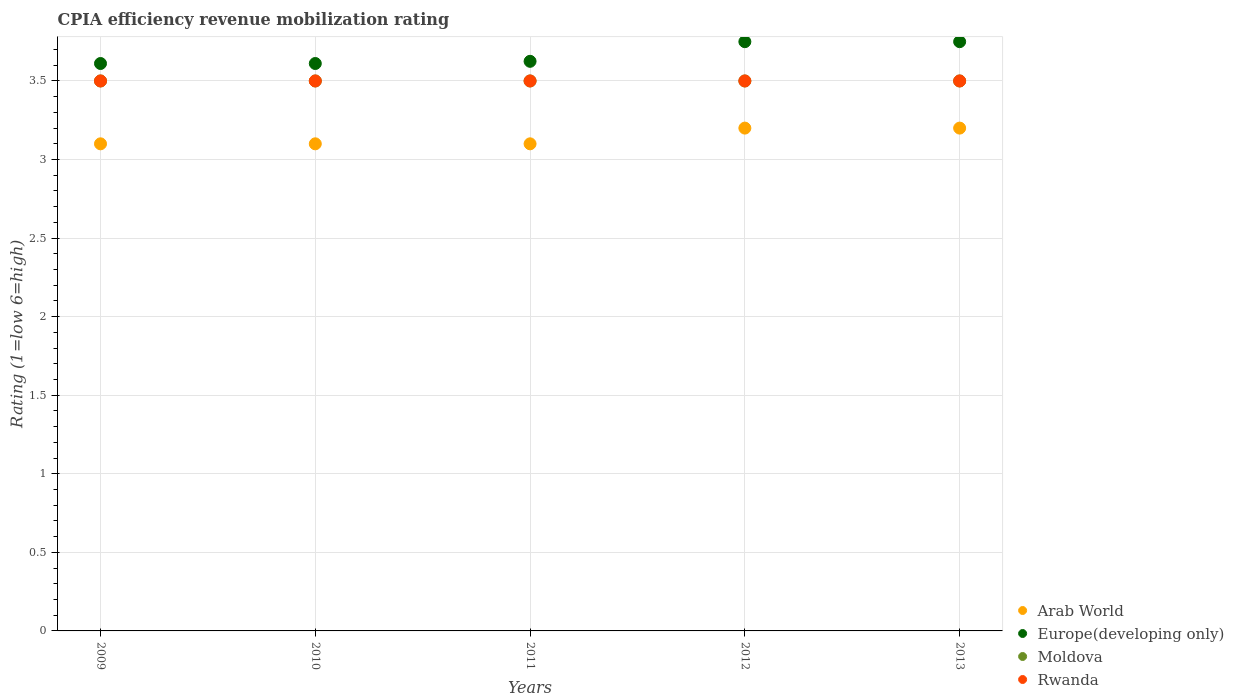Is the number of dotlines equal to the number of legend labels?
Offer a terse response. Yes. What is the CPIA rating in Arab World in 2013?
Your answer should be very brief. 3.2. Across all years, what is the maximum CPIA rating in Rwanda?
Give a very brief answer. 3.5. Across all years, what is the minimum CPIA rating in Moldova?
Make the answer very short. 3.5. In which year was the CPIA rating in Rwanda maximum?
Your response must be concise. 2009. In which year was the CPIA rating in Moldova minimum?
Ensure brevity in your answer.  2009. What is the difference between the CPIA rating in Arab World in 2012 and that in 2013?
Your answer should be compact. 0. What is the difference between the CPIA rating in Arab World in 2013 and the CPIA rating in Europe(developing only) in 2010?
Make the answer very short. -0.41. What is the average CPIA rating in Rwanda per year?
Your response must be concise. 3.5. In the year 2013, what is the difference between the CPIA rating in Arab World and CPIA rating in Europe(developing only)?
Offer a very short reply. -0.55. In how many years, is the CPIA rating in Arab World greater than 0.1?
Provide a short and direct response. 5. What is the ratio of the CPIA rating in Europe(developing only) in 2009 to that in 2010?
Offer a very short reply. 1. Is the CPIA rating in Moldova in 2011 less than that in 2012?
Your answer should be very brief. No. Is the difference between the CPIA rating in Arab World in 2009 and 2013 greater than the difference between the CPIA rating in Europe(developing only) in 2009 and 2013?
Provide a short and direct response. Yes. What is the difference between the highest and the second highest CPIA rating in Arab World?
Your answer should be compact. 0. What is the difference between the highest and the lowest CPIA rating in Arab World?
Offer a very short reply. 0.1. In how many years, is the CPIA rating in Arab World greater than the average CPIA rating in Arab World taken over all years?
Make the answer very short. 2. Is it the case that in every year, the sum of the CPIA rating in Europe(developing only) and CPIA rating in Moldova  is greater than the CPIA rating in Rwanda?
Provide a short and direct response. Yes. Does the CPIA rating in Rwanda monotonically increase over the years?
Your response must be concise. No. Is the CPIA rating in Arab World strictly greater than the CPIA rating in Moldova over the years?
Give a very brief answer. No. Does the graph contain grids?
Ensure brevity in your answer.  Yes. Where does the legend appear in the graph?
Your answer should be very brief. Bottom right. How many legend labels are there?
Provide a succinct answer. 4. How are the legend labels stacked?
Provide a succinct answer. Vertical. What is the title of the graph?
Make the answer very short. CPIA efficiency revenue mobilization rating. What is the label or title of the X-axis?
Your answer should be very brief. Years. What is the Rating (1=low 6=high) of Europe(developing only) in 2009?
Your answer should be very brief. 3.61. What is the Rating (1=low 6=high) in Rwanda in 2009?
Provide a short and direct response. 3.5. What is the Rating (1=low 6=high) of Europe(developing only) in 2010?
Your response must be concise. 3.61. What is the Rating (1=low 6=high) in Moldova in 2010?
Provide a succinct answer. 3.5. What is the Rating (1=low 6=high) in Rwanda in 2010?
Your response must be concise. 3.5. What is the Rating (1=low 6=high) of Arab World in 2011?
Your answer should be compact. 3.1. What is the Rating (1=low 6=high) of Europe(developing only) in 2011?
Offer a very short reply. 3.62. What is the Rating (1=low 6=high) in Moldova in 2011?
Give a very brief answer. 3.5. What is the Rating (1=low 6=high) of Arab World in 2012?
Give a very brief answer. 3.2. What is the Rating (1=low 6=high) of Europe(developing only) in 2012?
Your response must be concise. 3.75. What is the Rating (1=low 6=high) of Moldova in 2012?
Give a very brief answer. 3.5. What is the Rating (1=low 6=high) of Rwanda in 2012?
Give a very brief answer. 3.5. What is the Rating (1=low 6=high) in Europe(developing only) in 2013?
Give a very brief answer. 3.75. Across all years, what is the maximum Rating (1=low 6=high) of Arab World?
Offer a terse response. 3.2. Across all years, what is the maximum Rating (1=low 6=high) in Europe(developing only)?
Make the answer very short. 3.75. Across all years, what is the minimum Rating (1=low 6=high) of Arab World?
Offer a terse response. 3.1. Across all years, what is the minimum Rating (1=low 6=high) in Europe(developing only)?
Keep it short and to the point. 3.61. Across all years, what is the minimum Rating (1=low 6=high) of Moldova?
Make the answer very short. 3.5. Across all years, what is the minimum Rating (1=low 6=high) of Rwanda?
Your answer should be compact. 3.5. What is the total Rating (1=low 6=high) in Europe(developing only) in the graph?
Give a very brief answer. 18.35. What is the total Rating (1=low 6=high) in Moldova in the graph?
Offer a very short reply. 17.5. What is the difference between the Rating (1=low 6=high) in Arab World in 2009 and that in 2010?
Make the answer very short. 0. What is the difference between the Rating (1=low 6=high) of Europe(developing only) in 2009 and that in 2010?
Your response must be concise. 0. What is the difference between the Rating (1=low 6=high) of Moldova in 2009 and that in 2010?
Make the answer very short. 0. What is the difference between the Rating (1=low 6=high) in Rwanda in 2009 and that in 2010?
Provide a short and direct response. 0. What is the difference between the Rating (1=low 6=high) of Europe(developing only) in 2009 and that in 2011?
Offer a terse response. -0.01. What is the difference between the Rating (1=low 6=high) of Moldova in 2009 and that in 2011?
Make the answer very short. 0. What is the difference between the Rating (1=low 6=high) of Europe(developing only) in 2009 and that in 2012?
Your response must be concise. -0.14. What is the difference between the Rating (1=low 6=high) in Rwanda in 2009 and that in 2012?
Offer a very short reply. 0. What is the difference between the Rating (1=low 6=high) of Arab World in 2009 and that in 2013?
Provide a succinct answer. -0.1. What is the difference between the Rating (1=low 6=high) in Europe(developing only) in 2009 and that in 2013?
Provide a short and direct response. -0.14. What is the difference between the Rating (1=low 6=high) in Europe(developing only) in 2010 and that in 2011?
Your response must be concise. -0.01. What is the difference between the Rating (1=low 6=high) of Moldova in 2010 and that in 2011?
Your response must be concise. 0. What is the difference between the Rating (1=low 6=high) of Europe(developing only) in 2010 and that in 2012?
Make the answer very short. -0.14. What is the difference between the Rating (1=low 6=high) in Rwanda in 2010 and that in 2012?
Your response must be concise. 0. What is the difference between the Rating (1=low 6=high) of Europe(developing only) in 2010 and that in 2013?
Offer a very short reply. -0.14. What is the difference between the Rating (1=low 6=high) of Rwanda in 2010 and that in 2013?
Your response must be concise. 0. What is the difference between the Rating (1=low 6=high) of Europe(developing only) in 2011 and that in 2012?
Ensure brevity in your answer.  -0.12. What is the difference between the Rating (1=low 6=high) of Moldova in 2011 and that in 2012?
Offer a very short reply. 0. What is the difference between the Rating (1=low 6=high) in Rwanda in 2011 and that in 2012?
Your answer should be very brief. 0. What is the difference between the Rating (1=low 6=high) of Europe(developing only) in 2011 and that in 2013?
Give a very brief answer. -0.12. What is the difference between the Rating (1=low 6=high) of Arab World in 2012 and that in 2013?
Ensure brevity in your answer.  0. What is the difference between the Rating (1=low 6=high) in Rwanda in 2012 and that in 2013?
Ensure brevity in your answer.  0. What is the difference between the Rating (1=low 6=high) of Arab World in 2009 and the Rating (1=low 6=high) of Europe(developing only) in 2010?
Offer a very short reply. -0.51. What is the difference between the Rating (1=low 6=high) in Arab World in 2009 and the Rating (1=low 6=high) in Moldova in 2010?
Your answer should be very brief. -0.4. What is the difference between the Rating (1=low 6=high) of Arab World in 2009 and the Rating (1=low 6=high) of Rwanda in 2010?
Offer a terse response. -0.4. What is the difference between the Rating (1=low 6=high) in Europe(developing only) in 2009 and the Rating (1=low 6=high) in Rwanda in 2010?
Your answer should be very brief. 0.11. What is the difference between the Rating (1=low 6=high) of Moldova in 2009 and the Rating (1=low 6=high) of Rwanda in 2010?
Offer a terse response. 0. What is the difference between the Rating (1=low 6=high) in Arab World in 2009 and the Rating (1=low 6=high) in Europe(developing only) in 2011?
Offer a terse response. -0.53. What is the difference between the Rating (1=low 6=high) of Arab World in 2009 and the Rating (1=low 6=high) of Moldova in 2011?
Make the answer very short. -0.4. What is the difference between the Rating (1=low 6=high) of Europe(developing only) in 2009 and the Rating (1=low 6=high) of Moldova in 2011?
Ensure brevity in your answer.  0.11. What is the difference between the Rating (1=low 6=high) of Arab World in 2009 and the Rating (1=low 6=high) of Europe(developing only) in 2012?
Your response must be concise. -0.65. What is the difference between the Rating (1=low 6=high) in Arab World in 2009 and the Rating (1=low 6=high) in Moldova in 2012?
Offer a very short reply. -0.4. What is the difference between the Rating (1=low 6=high) of Arab World in 2009 and the Rating (1=low 6=high) of Rwanda in 2012?
Your answer should be compact. -0.4. What is the difference between the Rating (1=low 6=high) of Europe(developing only) in 2009 and the Rating (1=low 6=high) of Rwanda in 2012?
Your answer should be very brief. 0.11. What is the difference between the Rating (1=low 6=high) of Arab World in 2009 and the Rating (1=low 6=high) of Europe(developing only) in 2013?
Provide a short and direct response. -0.65. What is the difference between the Rating (1=low 6=high) of Europe(developing only) in 2009 and the Rating (1=low 6=high) of Rwanda in 2013?
Offer a terse response. 0.11. What is the difference between the Rating (1=low 6=high) in Moldova in 2009 and the Rating (1=low 6=high) in Rwanda in 2013?
Ensure brevity in your answer.  0. What is the difference between the Rating (1=low 6=high) in Arab World in 2010 and the Rating (1=low 6=high) in Europe(developing only) in 2011?
Offer a terse response. -0.53. What is the difference between the Rating (1=low 6=high) in Arab World in 2010 and the Rating (1=low 6=high) in Moldova in 2011?
Make the answer very short. -0.4. What is the difference between the Rating (1=low 6=high) of Arab World in 2010 and the Rating (1=low 6=high) of Rwanda in 2011?
Give a very brief answer. -0.4. What is the difference between the Rating (1=low 6=high) of Europe(developing only) in 2010 and the Rating (1=low 6=high) of Rwanda in 2011?
Ensure brevity in your answer.  0.11. What is the difference between the Rating (1=low 6=high) of Moldova in 2010 and the Rating (1=low 6=high) of Rwanda in 2011?
Keep it short and to the point. 0. What is the difference between the Rating (1=low 6=high) of Arab World in 2010 and the Rating (1=low 6=high) of Europe(developing only) in 2012?
Your answer should be very brief. -0.65. What is the difference between the Rating (1=low 6=high) of Arab World in 2010 and the Rating (1=low 6=high) of Moldova in 2012?
Your answer should be compact. -0.4. What is the difference between the Rating (1=low 6=high) in Europe(developing only) in 2010 and the Rating (1=low 6=high) in Moldova in 2012?
Your answer should be compact. 0.11. What is the difference between the Rating (1=low 6=high) in Moldova in 2010 and the Rating (1=low 6=high) in Rwanda in 2012?
Your response must be concise. 0. What is the difference between the Rating (1=low 6=high) of Arab World in 2010 and the Rating (1=low 6=high) of Europe(developing only) in 2013?
Make the answer very short. -0.65. What is the difference between the Rating (1=low 6=high) in Europe(developing only) in 2010 and the Rating (1=low 6=high) in Moldova in 2013?
Provide a short and direct response. 0.11. What is the difference between the Rating (1=low 6=high) in Arab World in 2011 and the Rating (1=low 6=high) in Europe(developing only) in 2012?
Keep it short and to the point. -0.65. What is the difference between the Rating (1=low 6=high) in Europe(developing only) in 2011 and the Rating (1=low 6=high) in Rwanda in 2012?
Provide a short and direct response. 0.12. What is the difference between the Rating (1=low 6=high) of Arab World in 2011 and the Rating (1=low 6=high) of Europe(developing only) in 2013?
Provide a short and direct response. -0.65. What is the difference between the Rating (1=low 6=high) in Arab World in 2011 and the Rating (1=low 6=high) in Moldova in 2013?
Offer a very short reply. -0.4. What is the difference between the Rating (1=low 6=high) in Arab World in 2012 and the Rating (1=low 6=high) in Europe(developing only) in 2013?
Provide a short and direct response. -0.55. What is the difference between the Rating (1=low 6=high) in Arab World in 2012 and the Rating (1=low 6=high) in Moldova in 2013?
Provide a short and direct response. -0.3. What is the difference between the Rating (1=low 6=high) in Europe(developing only) in 2012 and the Rating (1=low 6=high) in Rwanda in 2013?
Give a very brief answer. 0.25. What is the average Rating (1=low 6=high) in Arab World per year?
Give a very brief answer. 3.14. What is the average Rating (1=low 6=high) of Europe(developing only) per year?
Provide a succinct answer. 3.67. What is the average Rating (1=low 6=high) in Rwanda per year?
Your answer should be very brief. 3.5. In the year 2009, what is the difference between the Rating (1=low 6=high) in Arab World and Rating (1=low 6=high) in Europe(developing only)?
Ensure brevity in your answer.  -0.51. In the year 2009, what is the difference between the Rating (1=low 6=high) in Arab World and Rating (1=low 6=high) in Moldova?
Give a very brief answer. -0.4. In the year 2010, what is the difference between the Rating (1=low 6=high) in Arab World and Rating (1=low 6=high) in Europe(developing only)?
Offer a very short reply. -0.51. In the year 2010, what is the difference between the Rating (1=low 6=high) in Arab World and Rating (1=low 6=high) in Moldova?
Provide a succinct answer. -0.4. In the year 2010, what is the difference between the Rating (1=low 6=high) of Europe(developing only) and Rating (1=low 6=high) of Moldova?
Offer a very short reply. 0.11. In the year 2011, what is the difference between the Rating (1=low 6=high) of Arab World and Rating (1=low 6=high) of Europe(developing only)?
Give a very brief answer. -0.53. In the year 2011, what is the difference between the Rating (1=low 6=high) of Arab World and Rating (1=low 6=high) of Rwanda?
Ensure brevity in your answer.  -0.4. In the year 2012, what is the difference between the Rating (1=low 6=high) of Arab World and Rating (1=low 6=high) of Europe(developing only)?
Offer a very short reply. -0.55. In the year 2012, what is the difference between the Rating (1=low 6=high) in Arab World and Rating (1=low 6=high) in Moldova?
Offer a terse response. -0.3. In the year 2012, what is the difference between the Rating (1=low 6=high) of Europe(developing only) and Rating (1=low 6=high) of Moldova?
Provide a succinct answer. 0.25. In the year 2013, what is the difference between the Rating (1=low 6=high) of Arab World and Rating (1=low 6=high) of Europe(developing only)?
Ensure brevity in your answer.  -0.55. In the year 2013, what is the difference between the Rating (1=low 6=high) of Arab World and Rating (1=low 6=high) of Rwanda?
Provide a short and direct response. -0.3. In the year 2013, what is the difference between the Rating (1=low 6=high) of Europe(developing only) and Rating (1=low 6=high) of Moldova?
Give a very brief answer. 0.25. In the year 2013, what is the difference between the Rating (1=low 6=high) of Moldova and Rating (1=low 6=high) of Rwanda?
Keep it short and to the point. 0. What is the ratio of the Rating (1=low 6=high) in Arab World in 2009 to that in 2010?
Give a very brief answer. 1. What is the ratio of the Rating (1=low 6=high) of Europe(developing only) in 2009 to that in 2010?
Your answer should be very brief. 1. What is the ratio of the Rating (1=low 6=high) of Moldova in 2009 to that in 2010?
Your response must be concise. 1. What is the ratio of the Rating (1=low 6=high) of Arab World in 2009 to that in 2011?
Provide a succinct answer. 1. What is the ratio of the Rating (1=low 6=high) of Moldova in 2009 to that in 2011?
Your answer should be very brief. 1. What is the ratio of the Rating (1=low 6=high) of Arab World in 2009 to that in 2012?
Ensure brevity in your answer.  0.97. What is the ratio of the Rating (1=low 6=high) in Arab World in 2009 to that in 2013?
Offer a very short reply. 0.97. What is the ratio of the Rating (1=low 6=high) in Europe(developing only) in 2009 to that in 2013?
Keep it short and to the point. 0.96. What is the ratio of the Rating (1=low 6=high) in Moldova in 2009 to that in 2013?
Your answer should be very brief. 1. What is the ratio of the Rating (1=low 6=high) of Rwanda in 2009 to that in 2013?
Give a very brief answer. 1. What is the ratio of the Rating (1=low 6=high) of Europe(developing only) in 2010 to that in 2011?
Your answer should be very brief. 1. What is the ratio of the Rating (1=low 6=high) in Moldova in 2010 to that in 2011?
Provide a short and direct response. 1. What is the ratio of the Rating (1=low 6=high) in Arab World in 2010 to that in 2012?
Your answer should be very brief. 0.97. What is the ratio of the Rating (1=low 6=high) in Europe(developing only) in 2010 to that in 2012?
Give a very brief answer. 0.96. What is the ratio of the Rating (1=low 6=high) in Moldova in 2010 to that in 2012?
Your answer should be compact. 1. What is the ratio of the Rating (1=low 6=high) in Arab World in 2010 to that in 2013?
Your answer should be very brief. 0.97. What is the ratio of the Rating (1=low 6=high) in Moldova in 2010 to that in 2013?
Keep it short and to the point. 1. What is the ratio of the Rating (1=low 6=high) of Arab World in 2011 to that in 2012?
Offer a very short reply. 0.97. What is the ratio of the Rating (1=low 6=high) of Europe(developing only) in 2011 to that in 2012?
Offer a very short reply. 0.97. What is the ratio of the Rating (1=low 6=high) in Rwanda in 2011 to that in 2012?
Ensure brevity in your answer.  1. What is the ratio of the Rating (1=low 6=high) in Arab World in 2011 to that in 2013?
Give a very brief answer. 0.97. What is the ratio of the Rating (1=low 6=high) in Europe(developing only) in 2011 to that in 2013?
Give a very brief answer. 0.97. What is the ratio of the Rating (1=low 6=high) in Moldova in 2011 to that in 2013?
Your response must be concise. 1. What is the ratio of the Rating (1=low 6=high) in Arab World in 2012 to that in 2013?
Keep it short and to the point. 1. What is the ratio of the Rating (1=low 6=high) in Europe(developing only) in 2012 to that in 2013?
Provide a succinct answer. 1. What is the ratio of the Rating (1=low 6=high) in Moldova in 2012 to that in 2013?
Ensure brevity in your answer.  1. What is the difference between the highest and the second highest Rating (1=low 6=high) of Moldova?
Your response must be concise. 0. What is the difference between the highest and the lowest Rating (1=low 6=high) of Arab World?
Offer a very short reply. 0.1. What is the difference between the highest and the lowest Rating (1=low 6=high) of Europe(developing only)?
Provide a succinct answer. 0.14. 